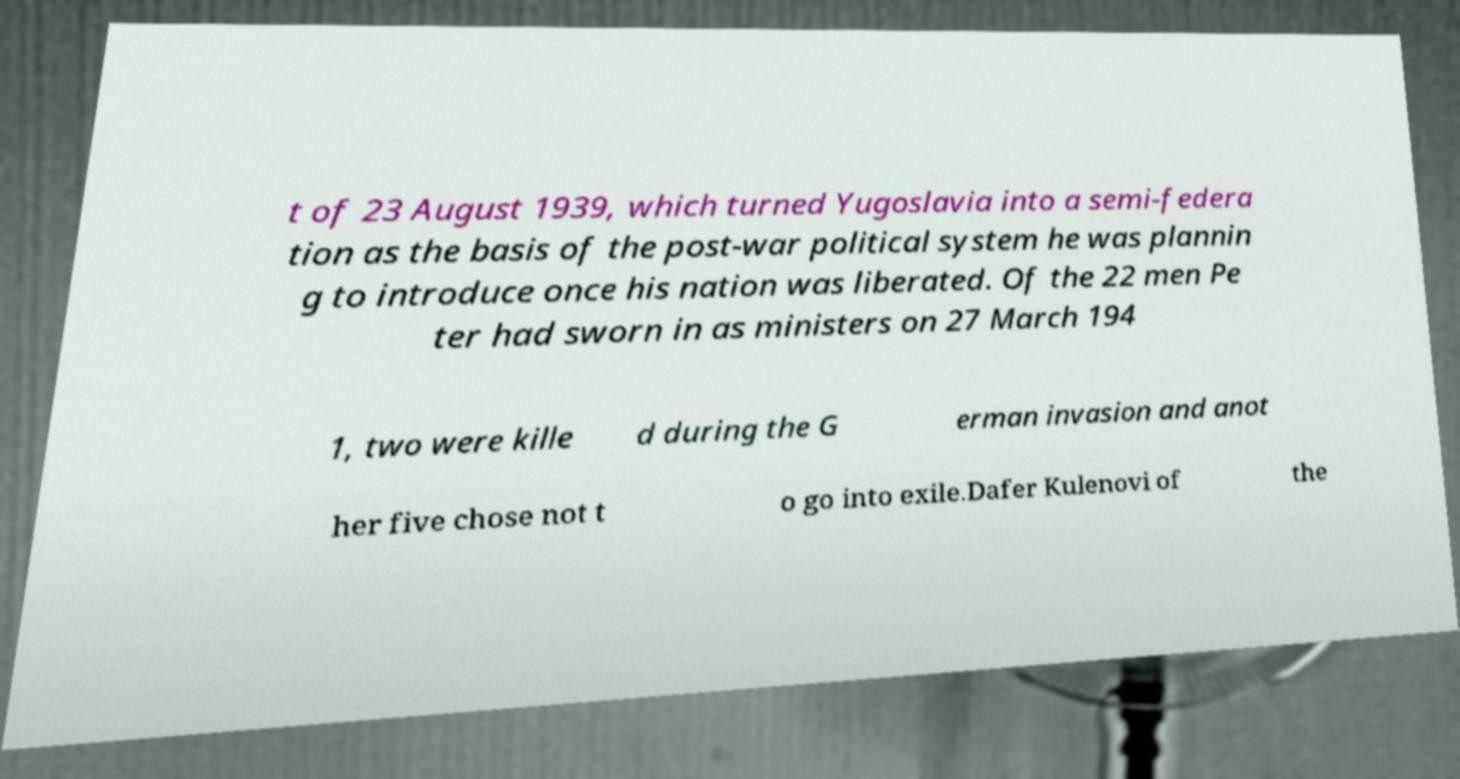I need the written content from this picture converted into text. Can you do that? t of 23 August 1939, which turned Yugoslavia into a semi-federa tion as the basis of the post-war political system he was plannin g to introduce once his nation was liberated. Of the 22 men Pe ter had sworn in as ministers on 27 March 194 1, two were kille d during the G erman invasion and anot her five chose not t o go into exile.Dafer Kulenovi of the 